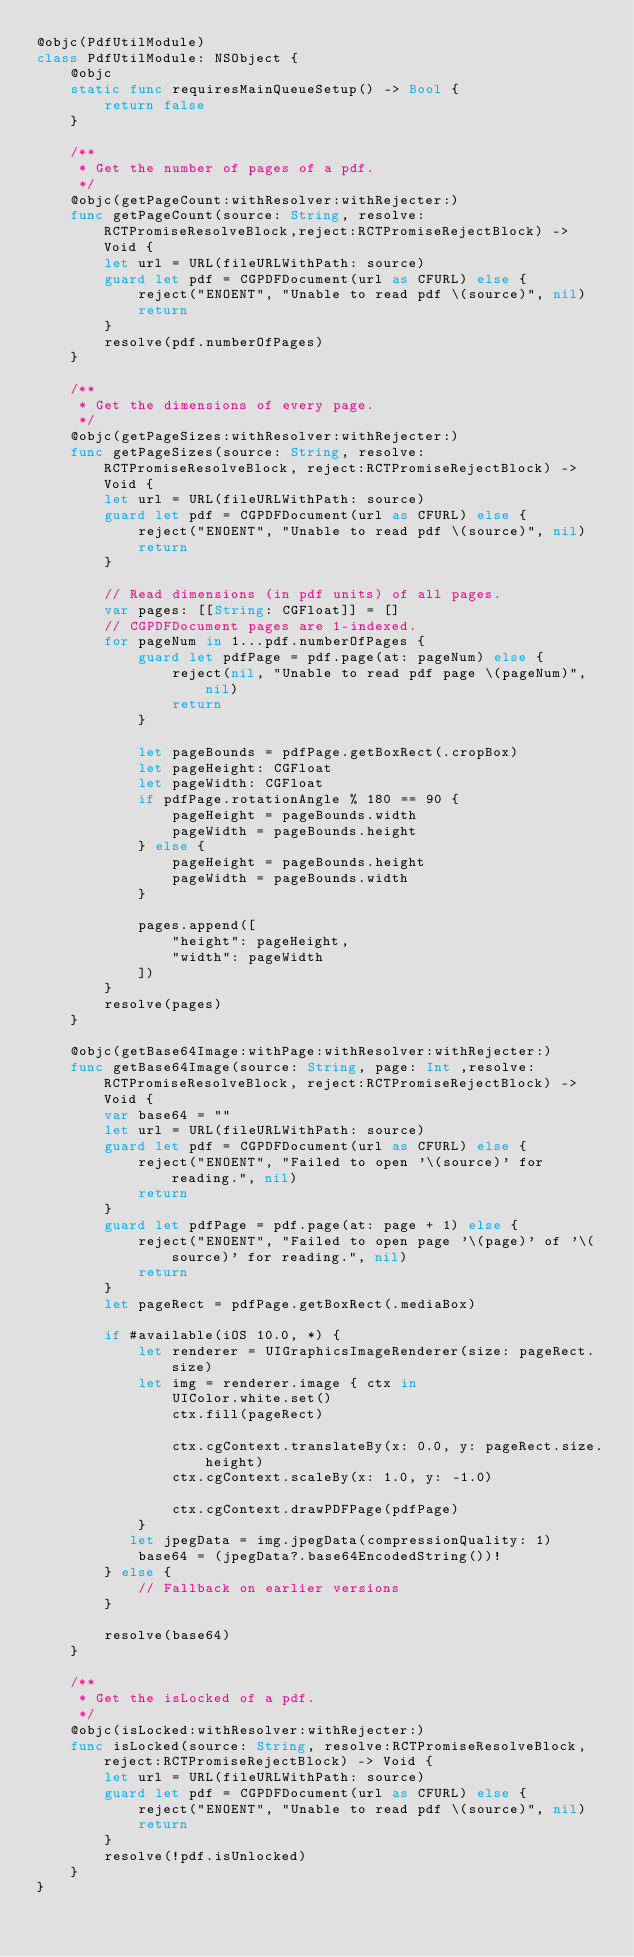<code> <loc_0><loc_0><loc_500><loc_500><_Swift_>@objc(PdfUtilModule)
class PdfUtilModule: NSObject {
    @objc
    static func requiresMainQueueSetup() -> Bool {
        return false
    }

    /**
     * Get the number of pages of a pdf.
     */
    @objc(getPageCount:withResolver:withRejecter:)
    func getPageCount(source: String, resolve:RCTPromiseResolveBlock,reject:RCTPromiseRejectBlock) -> Void {
        let url = URL(fileURLWithPath: source)
        guard let pdf = CGPDFDocument(url as CFURL) else {
            reject("ENOENT", "Unable to read pdf \(source)", nil)
            return
        }
        resolve(pdf.numberOfPages)
    }

    /**
     * Get the dimensions of every page.
     */
    @objc(getPageSizes:withResolver:withRejecter:)
    func getPageSizes(source: String, resolve:RCTPromiseResolveBlock, reject:RCTPromiseRejectBlock) -> Void {
        let url = URL(fileURLWithPath: source)
        guard let pdf = CGPDFDocument(url as CFURL) else {
            reject("ENOENT", "Unable to read pdf \(source)", nil)
            return
        }

        // Read dimensions (in pdf units) of all pages.
        var pages: [[String: CGFloat]] = []
        // CGPDFDocument pages are 1-indexed.
        for pageNum in 1...pdf.numberOfPages {
            guard let pdfPage = pdf.page(at: pageNum) else {
                reject(nil, "Unable to read pdf page \(pageNum)", nil)
                return
            }

            let pageBounds = pdfPage.getBoxRect(.cropBox)
            let pageHeight: CGFloat
            let pageWidth: CGFloat
            if pdfPage.rotationAngle % 180 == 90 {
                pageHeight = pageBounds.width
                pageWidth = pageBounds.height
            } else {
                pageHeight = pageBounds.height
                pageWidth = pageBounds.width
            }

            pages.append([
                "height": pageHeight,
                "width": pageWidth
            ])
        }
        resolve(pages)
    }
    
    @objc(getBase64Image:withPage:withResolver:withRejecter:)
    func getBase64Image(source: String, page: Int ,resolve:RCTPromiseResolveBlock, reject:RCTPromiseRejectBlock) -> Void {
        var base64 = ""
        let url = URL(fileURLWithPath: source)
        guard let pdf = CGPDFDocument(url as CFURL) else {
            reject("ENOENT", "Failed to open '\(source)' for reading.", nil)
            return
        }
        guard let pdfPage = pdf.page(at: page + 1) else {
            reject("ENOENT", "Failed to open page '\(page)' of '\(source)' for reading.", nil)
            return
        }
        let pageRect = pdfPage.getBoxRect(.mediaBox)
        
        if #available(iOS 10.0, *) {
            let renderer = UIGraphicsImageRenderer(size: pageRect.size)
            let img = renderer.image { ctx in
                UIColor.white.set()
                ctx.fill(pageRect)

                ctx.cgContext.translateBy(x: 0.0, y: pageRect.size.height)
                ctx.cgContext.scaleBy(x: 1.0, y: -1.0)

                ctx.cgContext.drawPDFPage(pdfPage)
            }
           let jpegData = img.jpegData(compressionQuality: 1)
            base64 = (jpegData?.base64EncodedString())!
        } else {
            // Fallback on earlier versions
        }
        
        resolve(base64)
    }

    /**
     * Get the isLocked of a pdf.
     */
    @objc(isLocked:withResolver:withRejecter:)
    func isLocked(source: String, resolve:RCTPromiseResolveBlock,reject:RCTPromiseRejectBlock) -> Void {
        let url = URL(fileURLWithPath: source)
        guard let pdf = CGPDFDocument(url as CFURL) else {
            reject("ENOENT", "Unable to read pdf \(source)", nil)
            return
        }
        resolve(!pdf.isUnlocked)
    }
}
</code> 